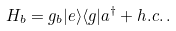Convert formula to latex. <formula><loc_0><loc_0><loc_500><loc_500>H _ { b } = g _ { b } | e \rangle \langle g | a ^ { \dagger } + h . c . \, .</formula> 